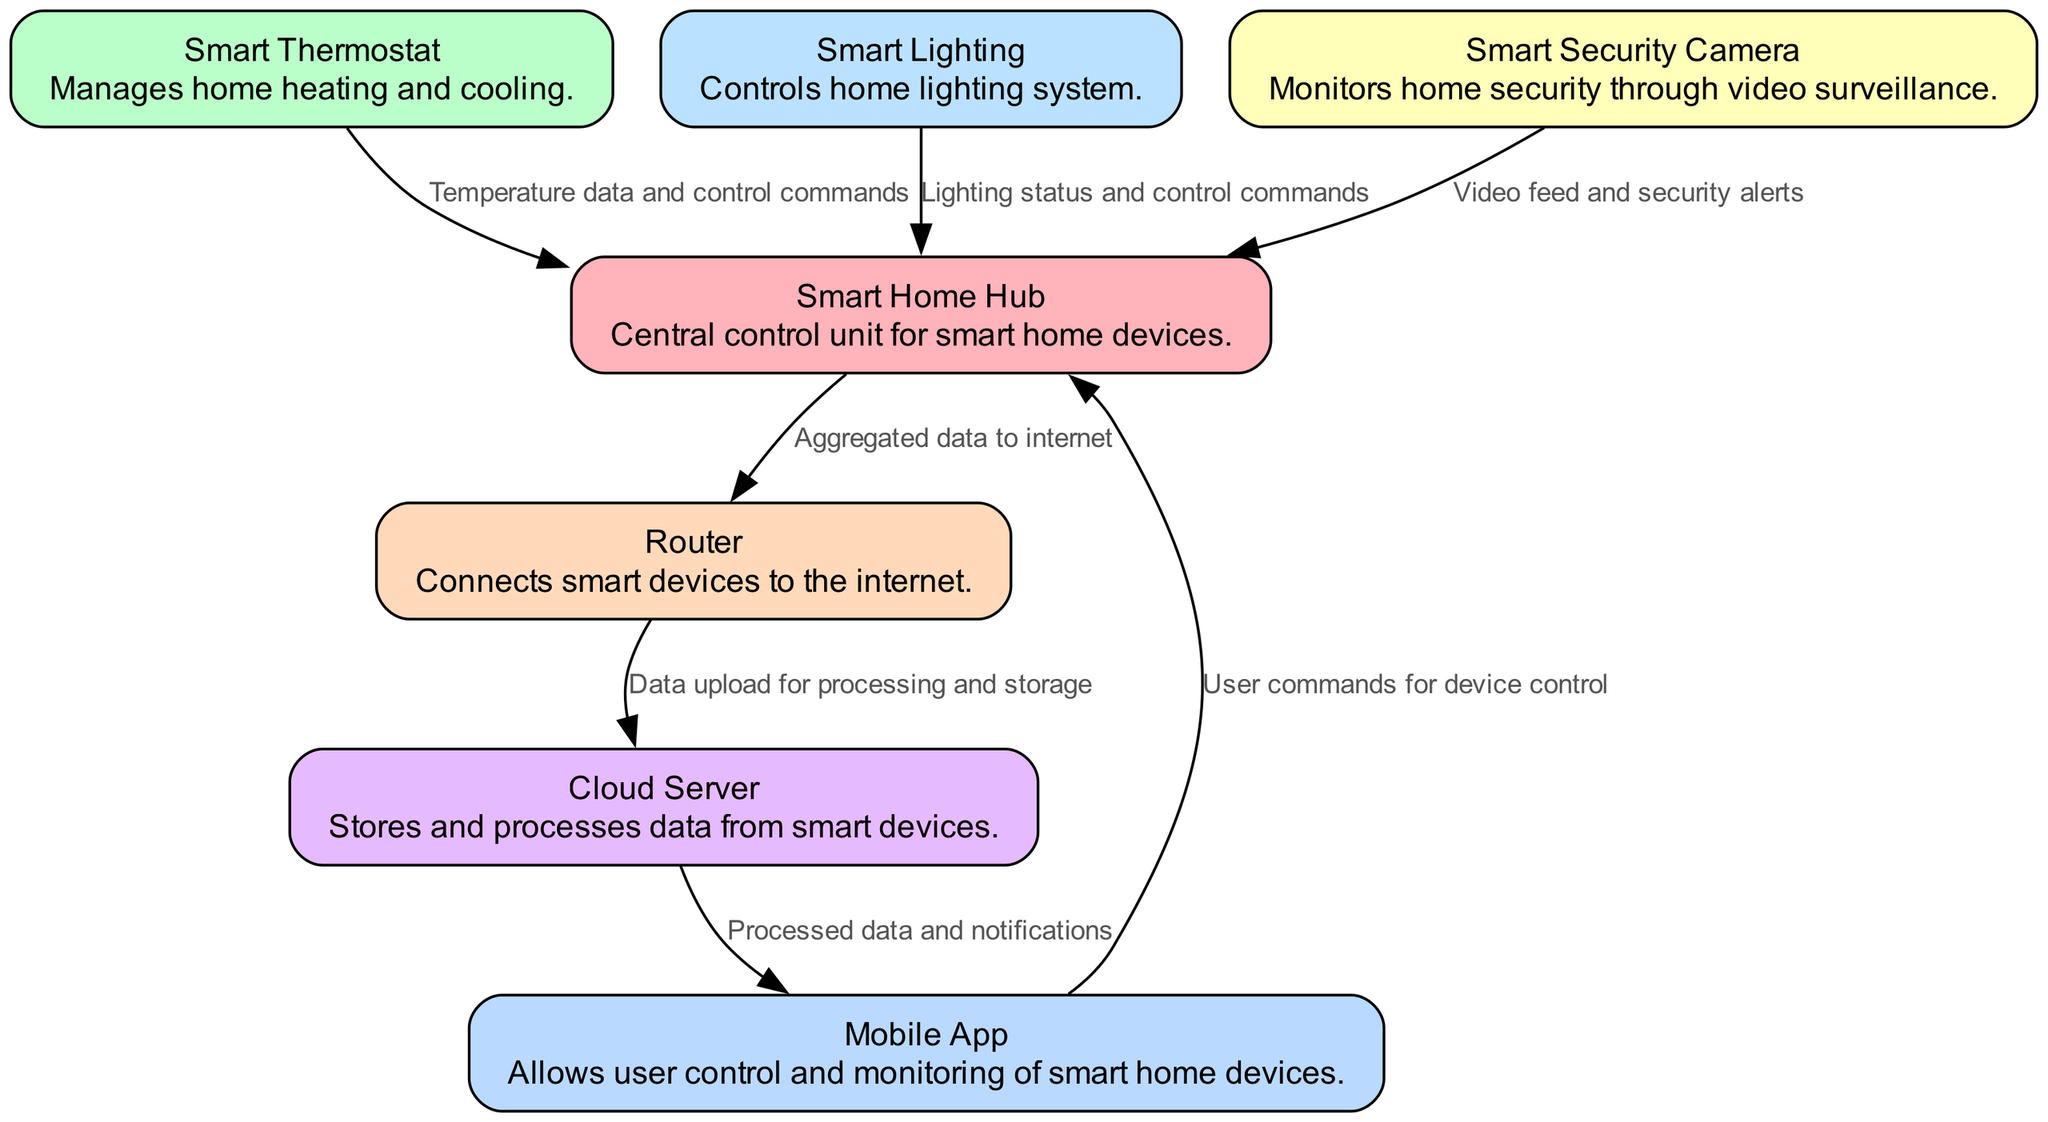What is the central unit for controlling smart home devices? The diagram identifies the "Smart Home Hub" as the central control unit, which connects and manages other smart devices like thermostats, lighting, and security cameras.
Answer: Smart Home Hub How many interconnected devices are shown in the diagram? The diagram lists four interconnected devices: Smart Thermostat, Smart Lighting, Smart Security Camera, and the Smart Home Hub itself, leading to a total of four distinct devices.
Answer: Four What type of data does the Smart Security Camera send to the Smart Home Hub? The diagram specifies that the Smart Security Camera sends "Video feed and security alerts" to the Smart Home Hub, indicating the type of information exchanged between the two.
Answer: Video feed and security alerts Which node receives user commands directly from the Mobile App? The diagram shows that the "Smart Home Hub" is the node that receives user commands from the Mobile App, as indicated by the direct edge specified between these two.
Answer: Smart Home Hub What is the relationship between the Router and Cloud Server? The diagram indicates that the Router is responsible for sending "Data upload for processing and storage" to the Cloud Server, depicting a clear data flow relationship between them.
Answer: Data upload for processing and storage Explain the flow of data from the Smart Lighting to the Cloud Server. The data flow begins with the Smart Lighting sending "Lighting status and control commands" to the Smart Home Hub. From there, the Smart Home Hub sends "Aggregated data to internet" through the Router, which then uploads "Data for processing and storage" to the Cloud Server.
Answer: Lighting status to Smart Home Hub, then to Router, and finally to Cloud Server What does the Cloud Server send to the Mobile App? The diagram notes that the Cloud Server transmits "Processed data and notifications" to the Mobile App, indicating what type of information is sent from the cloud environment to the application.
Answer: Processed data and notifications What color represents the Smart Thermostat in the diagram? The diagram includes a color coding scheme for the nodes, indicating that the Smart Thermostat is represented by the color "#BAFFC9," which differentiates it from the other nodes visually.
Answer: #BAFFC9 How does the Smart Home Hub connect to the internet? The diagram shows that the Smart Home Hub connects to the internet via the Router, which is indicated as the intermediary node transferring "Aggregated data to internet."
Answer: Router 